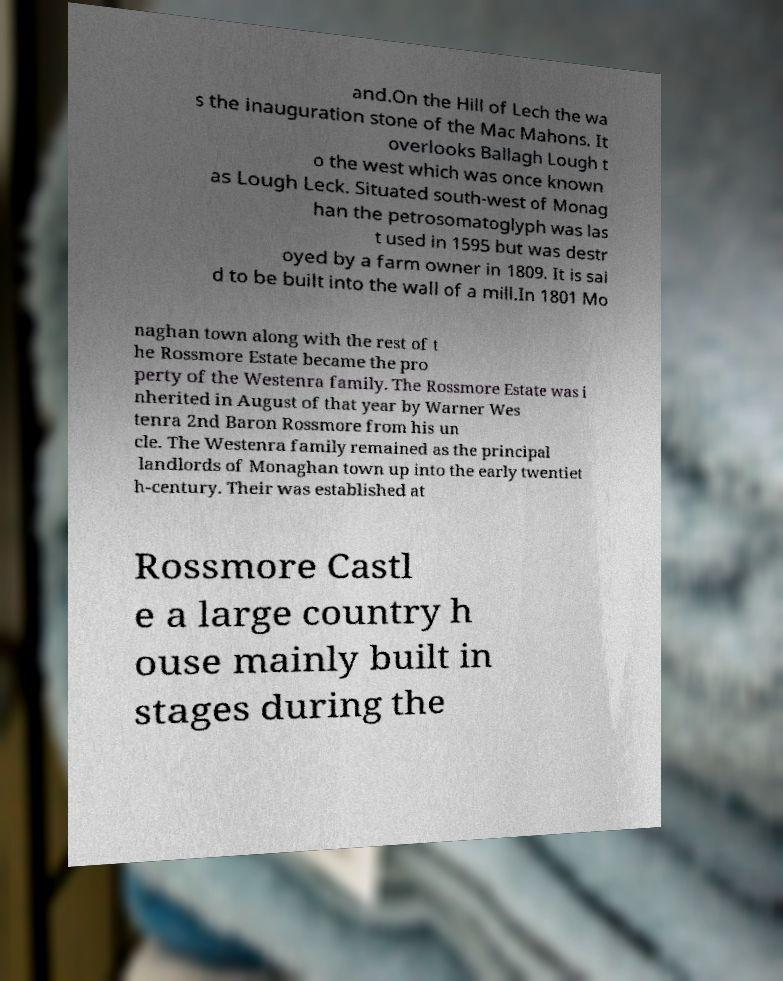Please identify and transcribe the text found in this image. and.On the Hill of Lech the wa s the inauguration stone of the Mac Mahons. It overlooks Ballagh Lough t o the west which was once known as Lough Leck. Situated south-west of Monag han the petrosomatoglyph was las t used in 1595 but was destr oyed by a farm owner in 1809. It is sai d to be built into the wall of a mill.In 1801 Mo naghan town along with the rest of t he Rossmore Estate became the pro perty of the Westenra family. The Rossmore Estate was i nherited in August of that year by Warner Wes tenra 2nd Baron Rossmore from his un cle. The Westenra family remained as the principal landlords of Monaghan town up into the early twentiet h-century. Their was established at Rossmore Castl e a large country h ouse mainly built in stages during the 